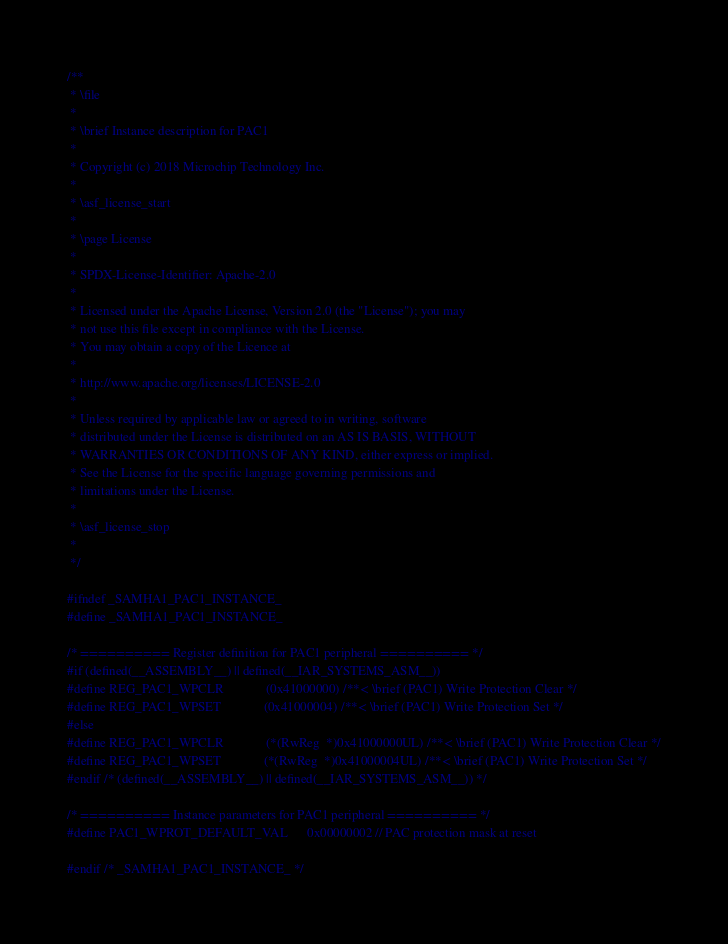<code> <loc_0><loc_0><loc_500><loc_500><_C_>/**
 * \file
 *
 * \brief Instance description for PAC1
 *
 * Copyright (c) 2018 Microchip Technology Inc.
 *
 * \asf_license_start
 *
 * \page License
 *
 * SPDX-License-Identifier: Apache-2.0
 *
 * Licensed under the Apache License, Version 2.0 (the "License"); you may
 * not use this file except in compliance with the License.
 * You may obtain a copy of the Licence at
 * 
 * http://www.apache.org/licenses/LICENSE-2.0
 * 
 * Unless required by applicable law or agreed to in writing, software
 * distributed under the License is distributed on an AS IS BASIS, WITHOUT
 * WARRANTIES OR CONDITIONS OF ANY KIND, either express or implied.
 * See the License for the specific language governing permissions and
 * limitations under the License.
 *
 * \asf_license_stop
 *
 */

#ifndef _SAMHA1_PAC1_INSTANCE_
#define _SAMHA1_PAC1_INSTANCE_

/* ========== Register definition for PAC1 peripheral ========== */
#if (defined(__ASSEMBLY__) || defined(__IAR_SYSTEMS_ASM__))
#define REG_PAC1_WPCLR             (0x41000000) /**< \brief (PAC1) Write Protection Clear */
#define REG_PAC1_WPSET             (0x41000004) /**< \brief (PAC1) Write Protection Set */
#else
#define REG_PAC1_WPCLR             (*(RwReg  *)0x41000000UL) /**< \brief (PAC1) Write Protection Clear */
#define REG_PAC1_WPSET             (*(RwReg  *)0x41000004UL) /**< \brief (PAC1) Write Protection Set */
#endif /* (defined(__ASSEMBLY__) || defined(__IAR_SYSTEMS_ASM__)) */

/* ========== Instance parameters for PAC1 peripheral ========== */
#define PAC1_WPROT_DEFAULT_VAL      0x00000002 // PAC protection mask at reset

#endif /* _SAMHA1_PAC1_INSTANCE_ */
</code> 